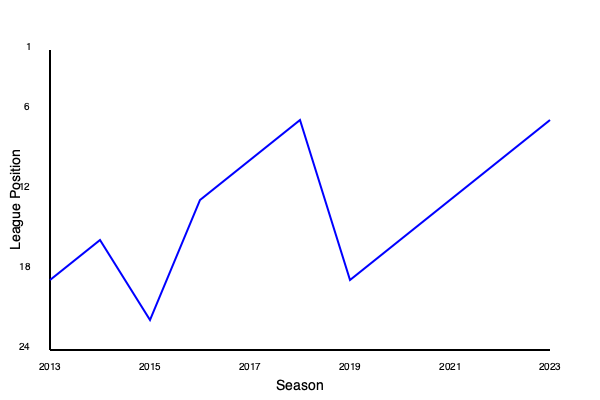Based on the line graph showing Peterborough United's league positions over the past decade, in which season did the club achieve its highest league position, and what was that position? To answer this question, we need to analyze the line graph of Peterborough United's league positions from 2013 to 2023:

1. The y-axis represents the league position, with lower numbers indicating higher positions (1 being the highest).
2. The x-axis represents the seasons from 2013 to 2023.
3. We need to find the lowest point on the graph, which corresponds to the highest league position.

Examining the graph:
- The line starts at a relatively low position in 2013.
- It fluctuates over the years, showing both improvements and declines.
- The lowest point on the graph (highest league position) occurs at the far right of the graph, corresponding to the 2023 season.
- This point appears to be at the level of the 6th position on the y-axis.

Therefore, Peterborough United achieved its highest league position in the 2023 season, reaching approximately the 6th position in the league.
Answer: 2023 season, 6th position 